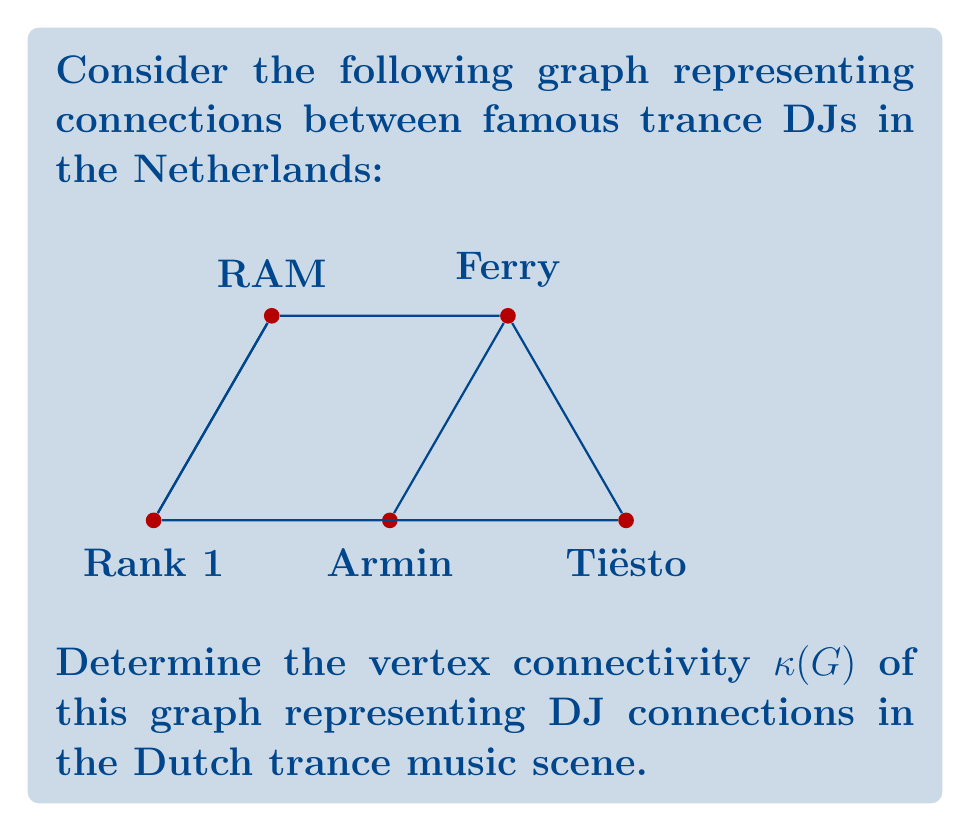Show me your answer to this math problem. To find the vertex connectivity $\kappa(G)$ of the graph, we need to determine the minimum number of vertices that need to be removed to disconnect the graph.

Step 1: Analyze the graph structure.
The graph has 5 vertices representing DJs: Armin, Tiësto, Ferry, Rank 1, and RAM.

Step 2: Check for potential cut vertices.
A cut vertex is a vertex whose removal increases the number of connected components. In this graph:
- Removing Ferry disconnects RAM from the rest of the graph.
- Removing Rank 1 disconnects RAM from the rest of the graph.
- No other single vertex disconnects the graph.

Step 3: Determine the minimum number of vertices to disconnect the graph.
Since removing either Ferry or Rank 1 alone can disconnect the graph, the minimum number of vertices needed is 1.

Step 4: Verify that removing any single vertex other than Ferry or Rank 1 does not disconnect the graph.
- Removing Armin: The graph remains connected through Tiësto-Ferry-Rank 1-RAM.
- Removing Tiësto: The graph remains connected through Armin-Ferry-Rank 1-RAM.
- Removing RAM: The graph remains connected through the other four vertices.

Step 5: Conclude the vertex connectivity.
The vertex connectivity $\kappa(G)$ is equal to the minimum number of vertices that need to be removed to disconnect the graph, which is 1.

Therefore, $\kappa(G) = 1$.
Answer: $\kappa(G) = 1$ 